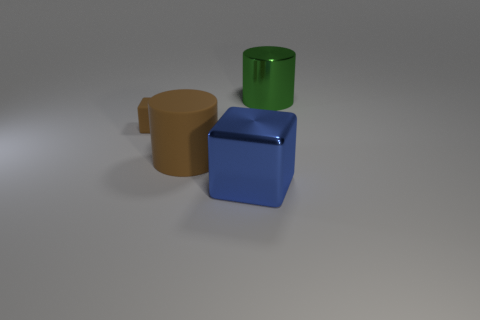There is a large green cylinder that is to the right of the brown matte cube behind the large block; what is its material?
Give a very brief answer. Metal. Is there a green cylinder that has the same size as the brown matte cube?
Give a very brief answer. No. What number of things are either large brown objects that are right of the brown block or objects that are to the right of the large brown rubber cylinder?
Offer a terse response. 3. Do the brown matte object left of the rubber cylinder and the cylinder in front of the brown matte block have the same size?
Keep it short and to the point. No. Are there any big green metal cylinders that are in front of the cylinder to the right of the metallic block?
Your answer should be very brief. No. How many blue objects are right of the small cube?
Your response must be concise. 1. What number of other things are there of the same color as the large metal cube?
Your answer should be compact. 0. Is the number of things that are behind the large green thing less than the number of cylinders that are behind the large brown matte cylinder?
Your answer should be very brief. Yes. What number of things are either large objects that are in front of the large metallic cylinder or big brown matte spheres?
Keep it short and to the point. 2. Do the rubber cube and the block in front of the brown rubber cube have the same size?
Your answer should be compact. No. 